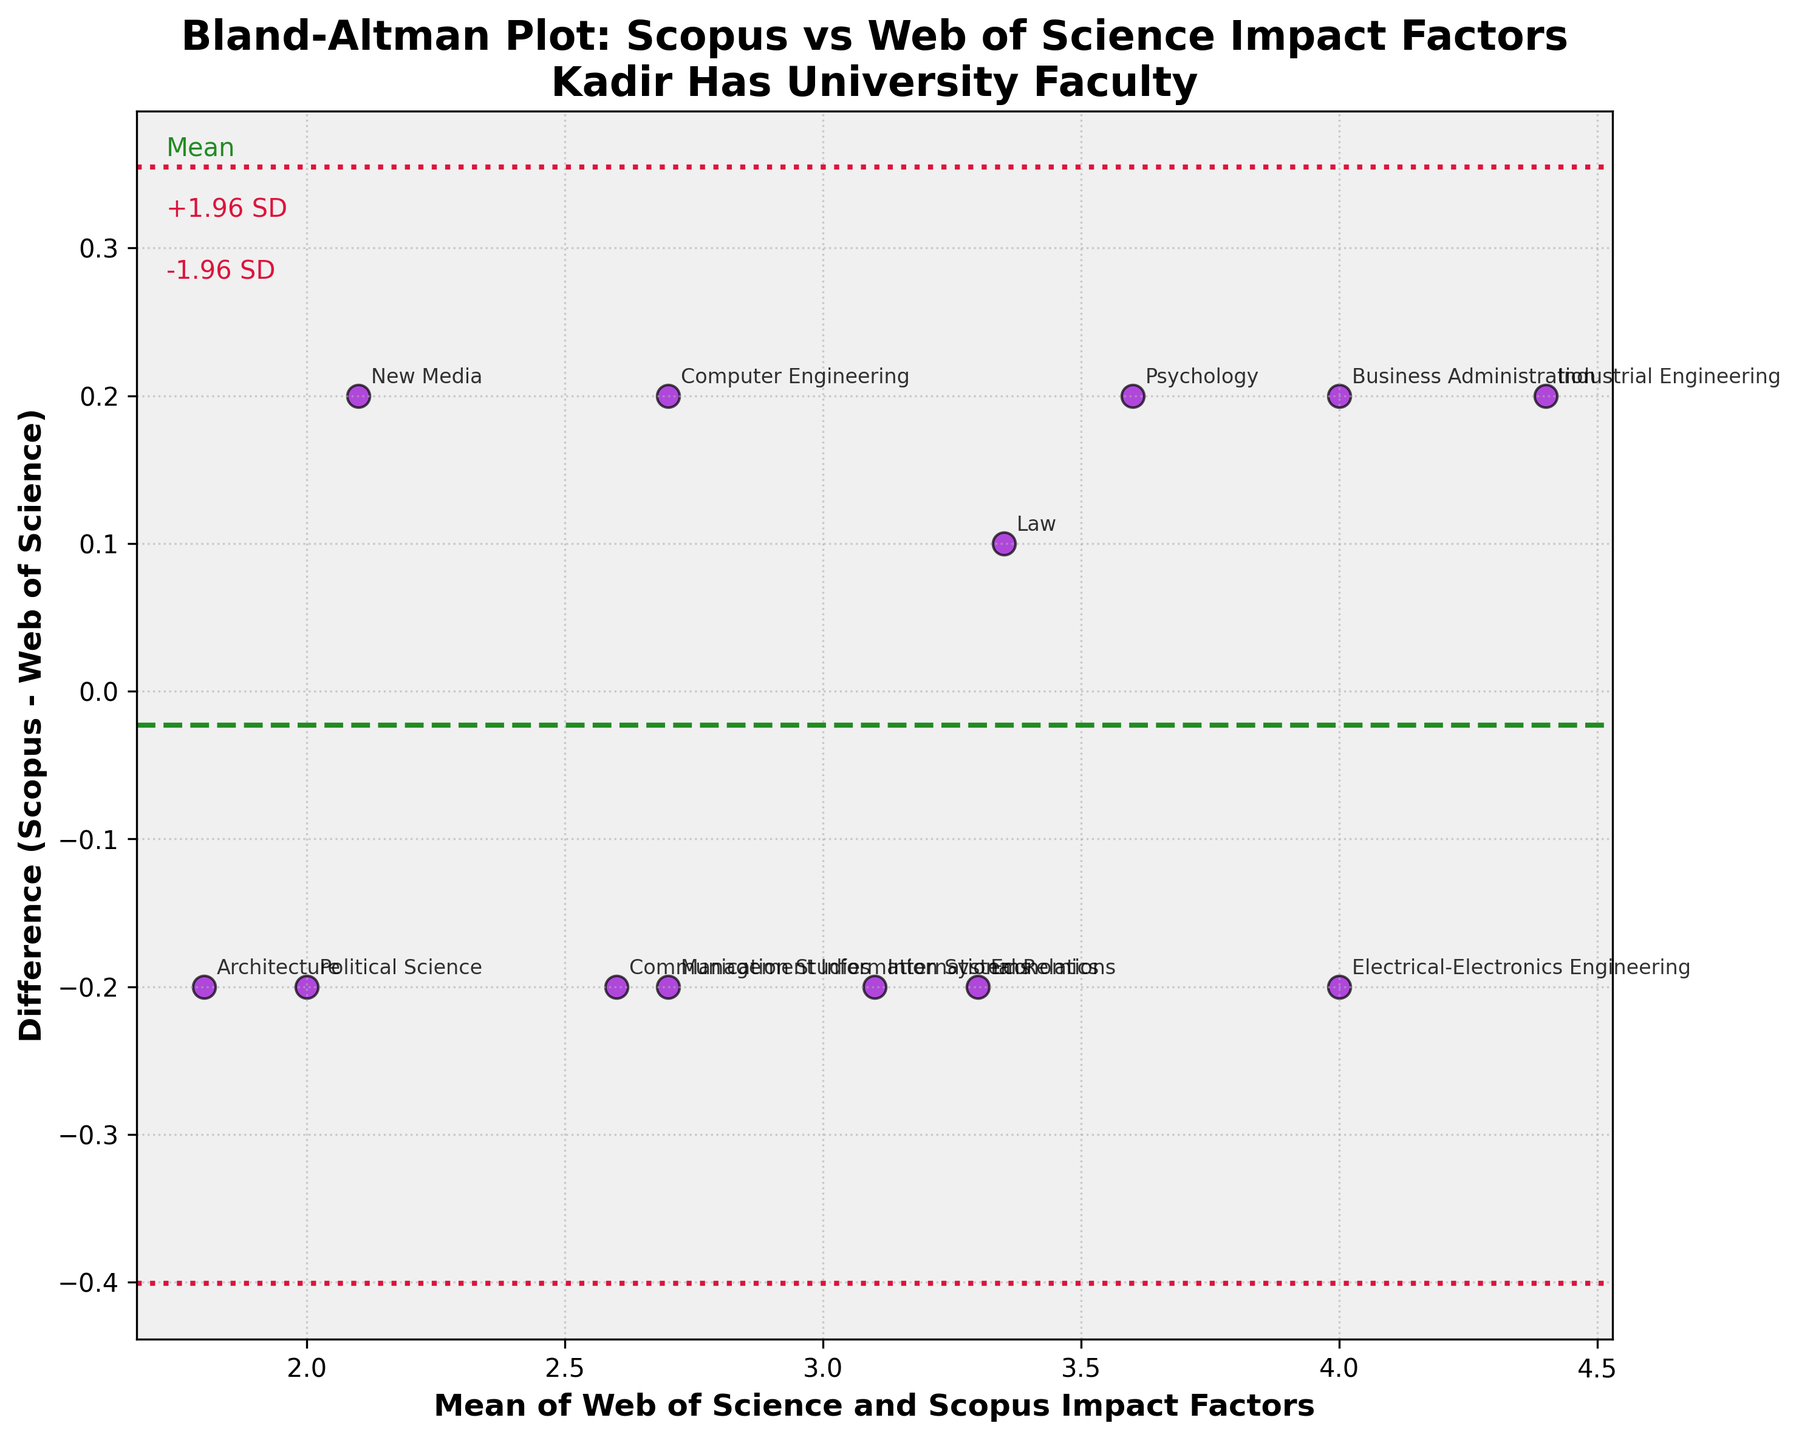What's the title of the figure? The title is usually found at the top of the figure, and in this case, it is clearly stated.
Answer: Bland-Altman Plot: Scopus vs Web of Science Impact Factors\nKadir Has University Faculty How many departments are represented in the plot? By counting the number of data points (or annotations) on the plot, each representing a department, we can determine the total number of departments.
Answer: 13 What is the mean of the differences in impact factors between Scopus and Web of Science? The mean of the differences is represented by the green dashed horizontal line, labeled as 'Mean'.
Answer: Approximately -0.014 Which department has the largest positive difference between Scopus and Web of Science impact factors? By observing the data points above the zero-difference line and their annotations, we can identify the department with the highest positive value.
Answer: Industrial Engineering Are the differences between Scopus and Web of Science impact factors for the majority of departments higher or lower than the mean difference? By comparing the position of most data points relative to the mean difference line, we can determine if they lie above or below it.
Answer: Higher What can be inferred from the +1.96 SD and -1.96 SD lines? These lines, usually shown with dotted lines, represent the range within which 95% of the differences are expected to fall, giving insight into the variability and agreement between the two databases.
Answer: Most differences fall within these limits Which data point represents the Political Science department? Locate the specific annotation for the Political Science department on the plot and identify its position.
Answer: Approximately (2.0, -0.2) Which departments fall outside the ±1.96 SD range? By identifying the data points that lie above the upper or below the lower dotted lines (+1.96 SD and -1.96 SD respectively), we can determine which departments are outside this range.
Answer: None On average, do the impacts of Scopus tend to be higher or lower than those of Web of Science for Kadir Has University faculty? By observing if the majority of differences (data points) lie above or below the zero-difference line, we can infer the general trend.
Answer: Slightly lower What is the impact factor difference for the Communication Studies department? Locate the data point annotated as Communication Studies and read off its vertical position (difference).
Answer: 0.2 